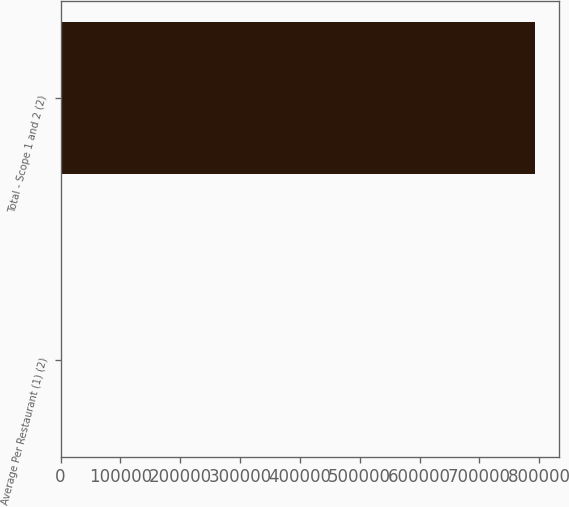<chart> <loc_0><loc_0><loc_500><loc_500><bar_chart><fcel>Average Per Restaurant (1) (2)<fcel>Total - Scope 1 and 2 (2)<nl><fcel>519<fcel>792893<nl></chart> 